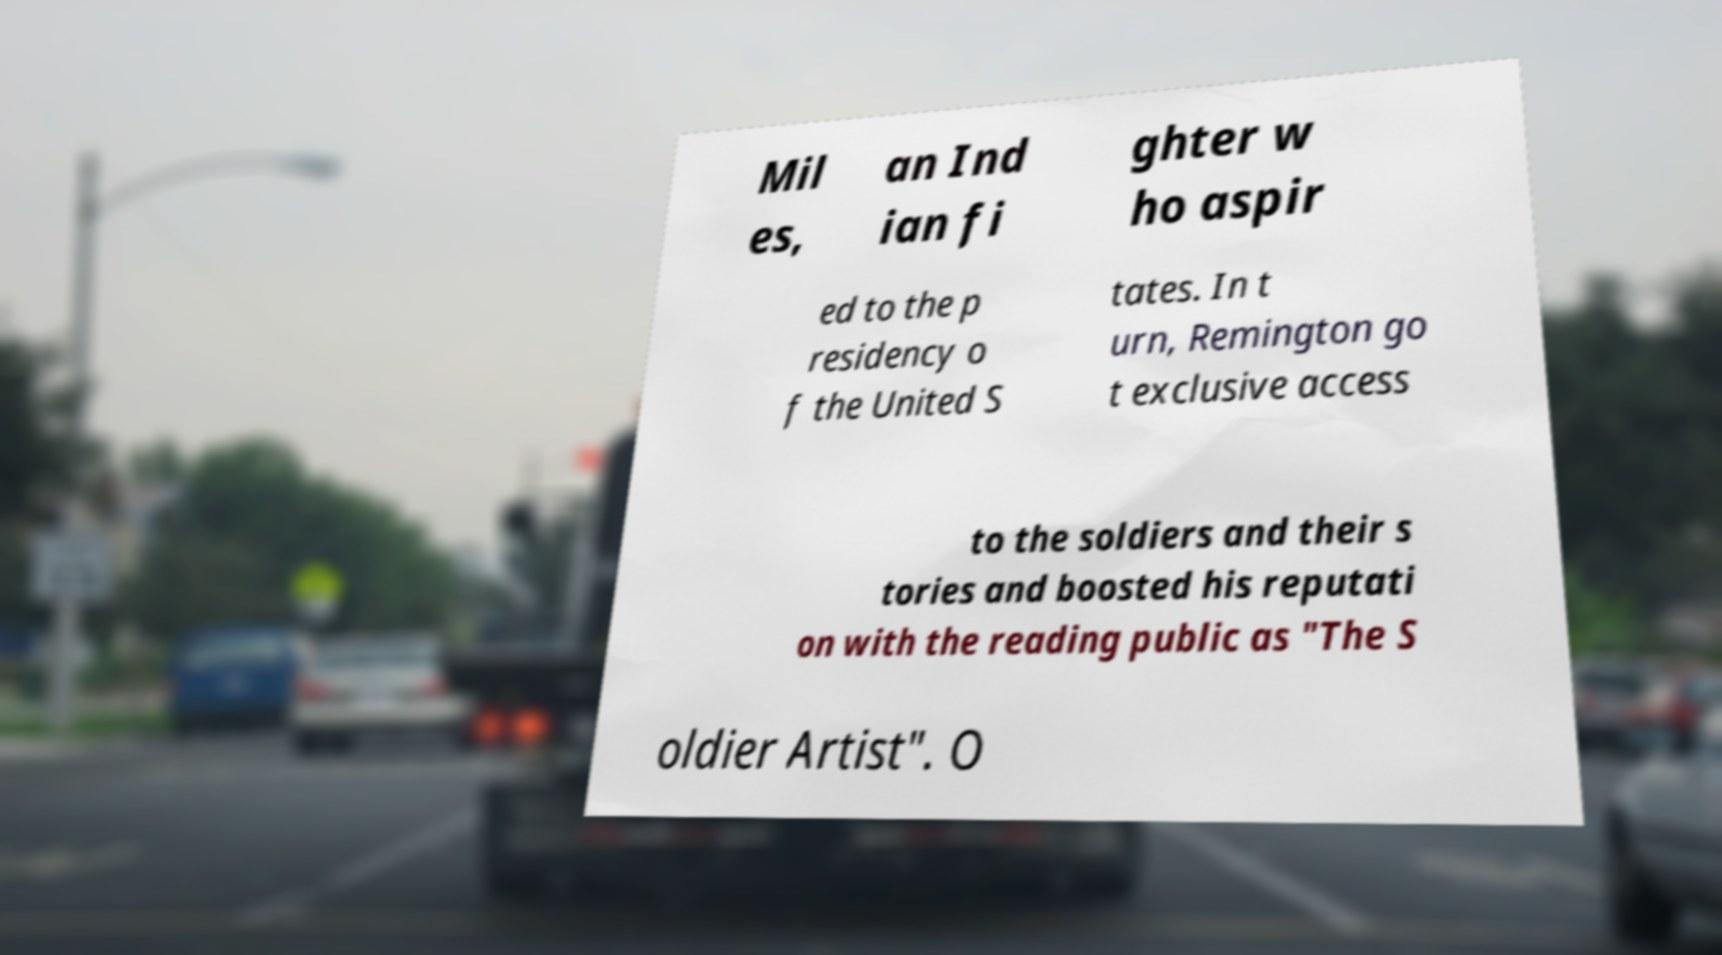Can you read and provide the text displayed in the image?This photo seems to have some interesting text. Can you extract and type it out for me? Mil es, an Ind ian fi ghter w ho aspir ed to the p residency o f the United S tates. In t urn, Remington go t exclusive access to the soldiers and their s tories and boosted his reputati on with the reading public as "The S oldier Artist". O 